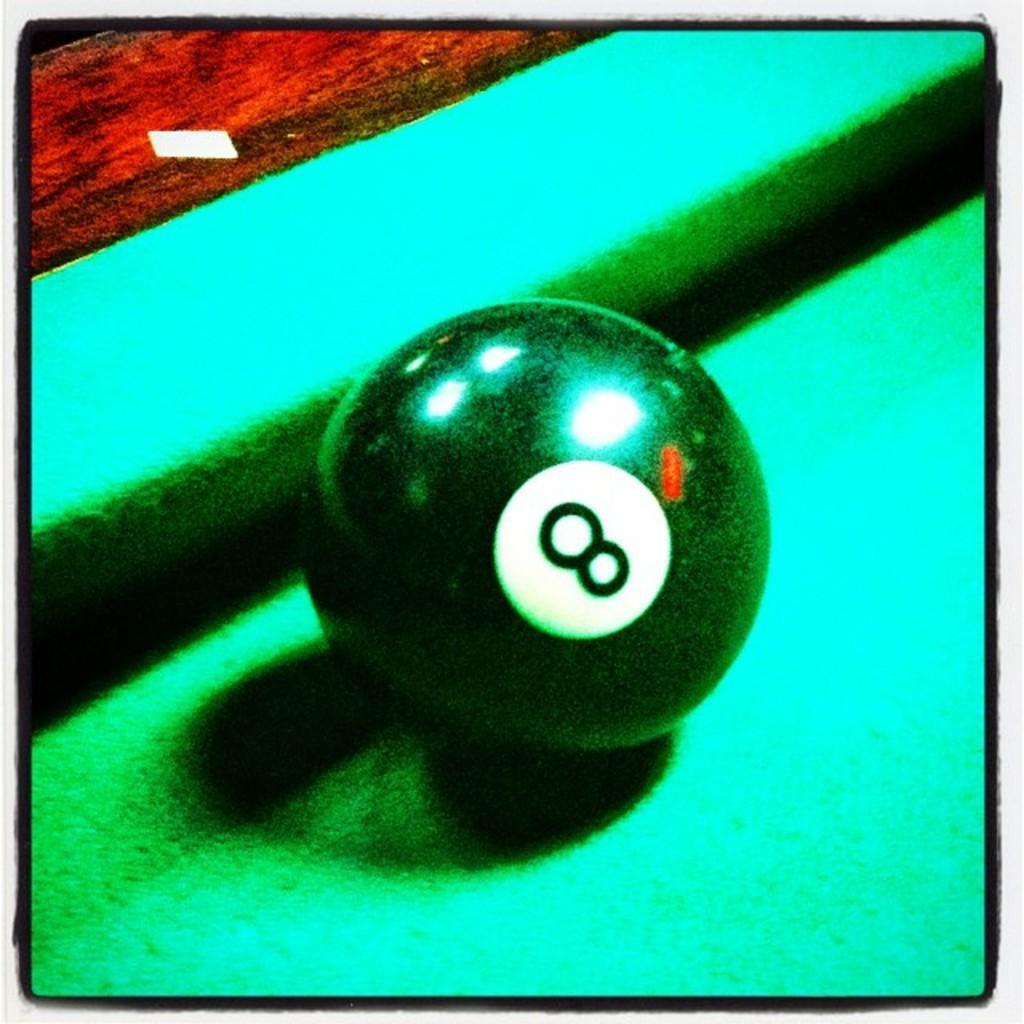How would you summarize this image in a sentence or two? In this image we can see a billiard ball on the table and the image has borders. 